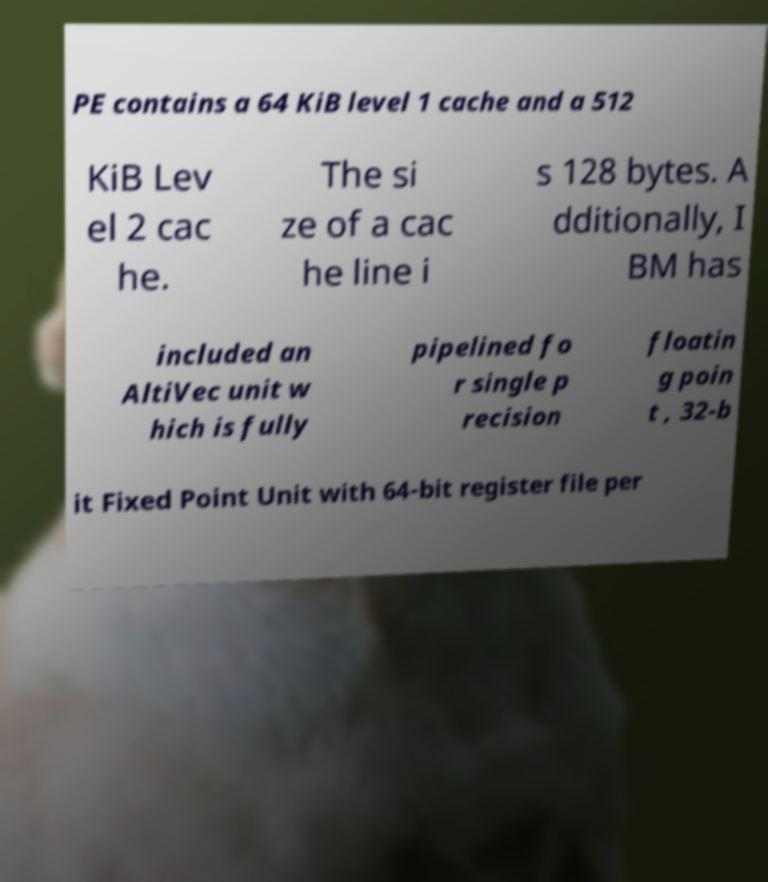Please identify and transcribe the text found in this image. PE contains a 64 KiB level 1 cache and a 512 KiB Lev el 2 cac he. The si ze of a cac he line i s 128 bytes. A dditionally, I BM has included an AltiVec unit w hich is fully pipelined fo r single p recision floatin g poin t , 32-b it Fixed Point Unit with 64-bit register file per 